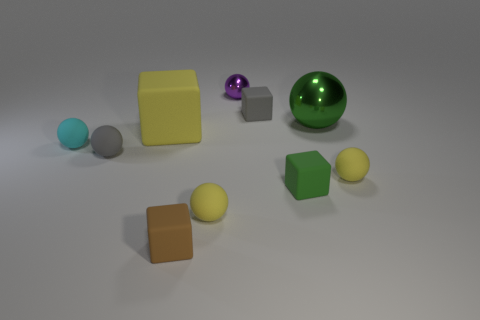Subtract all purple spheres. How many spheres are left? 5 Subtract all red cylinders. How many yellow balls are left? 2 Subtract all yellow cubes. How many cubes are left? 3 Subtract 2 cubes. How many cubes are left? 2 Subtract all brown spheres. Subtract all brown cylinders. How many spheres are left? 6 Subtract all blocks. How many objects are left? 6 Add 6 purple metallic things. How many purple metallic things are left? 7 Add 6 gray matte things. How many gray matte things exist? 8 Subtract 1 green cubes. How many objects are left? 9 Subtract all small yellow rubber things. Subtract all tiny matte balls. How many objects are left? 4 